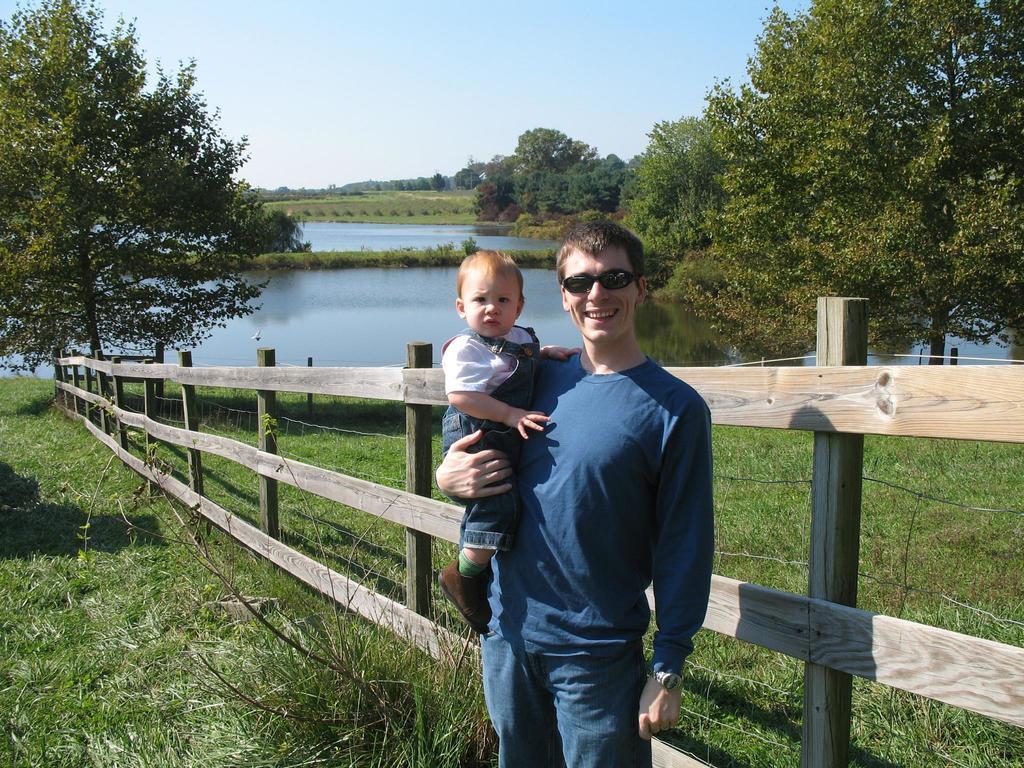In one or two sentences, can you explain what this image depicts? In the middle of the image we can see a man, he is holding a baby, he wore spectacles and he is smiling, behind him we can see fence, grass, few trees and water. 